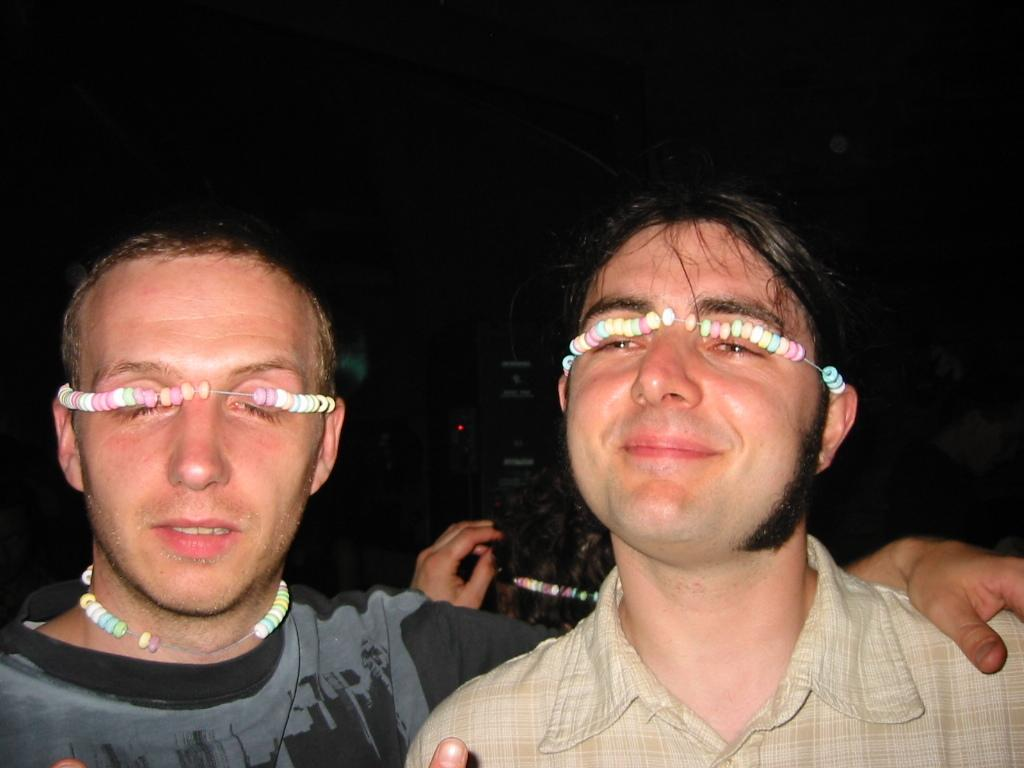Who or what can be seen in the image? There are people in the image. What are the people wearing in the image? The people are wearing chains in the image. What can be observed about the background of the image? The background of the image is dark. What type of ring can be seen on the people's fingers in the image? There are no rings visible on the people's fingers in the image; they are wearing chains. 